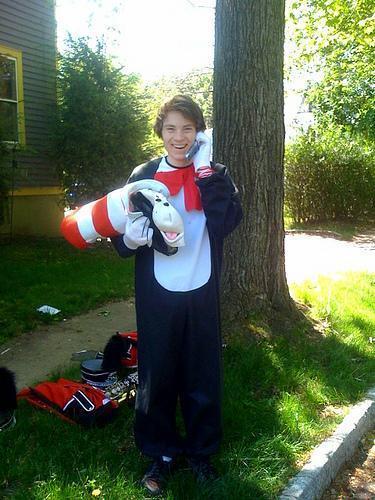How many zebras are there?
Give a very brief answer. 0. 